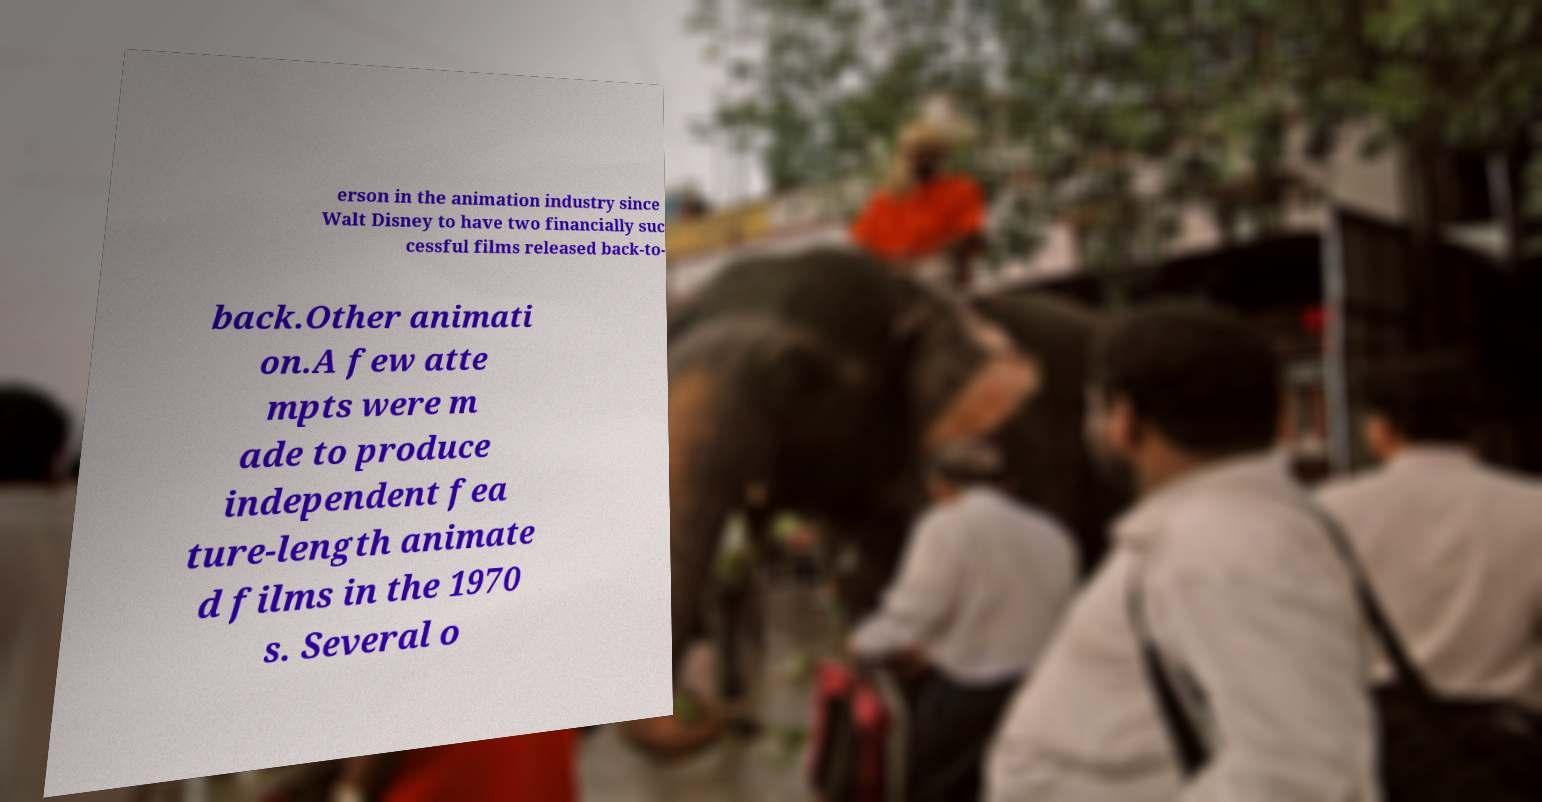There's text embedded in this image that I need extracted. Can you transcribe it verbatim? erson in the animation industry since Walt Disney to have two financially suc cessful films released back-to- back.Other animati on.A few atte mpts were m ade to produce independent fea ture-length animate d films in the 1970 s. Several o 